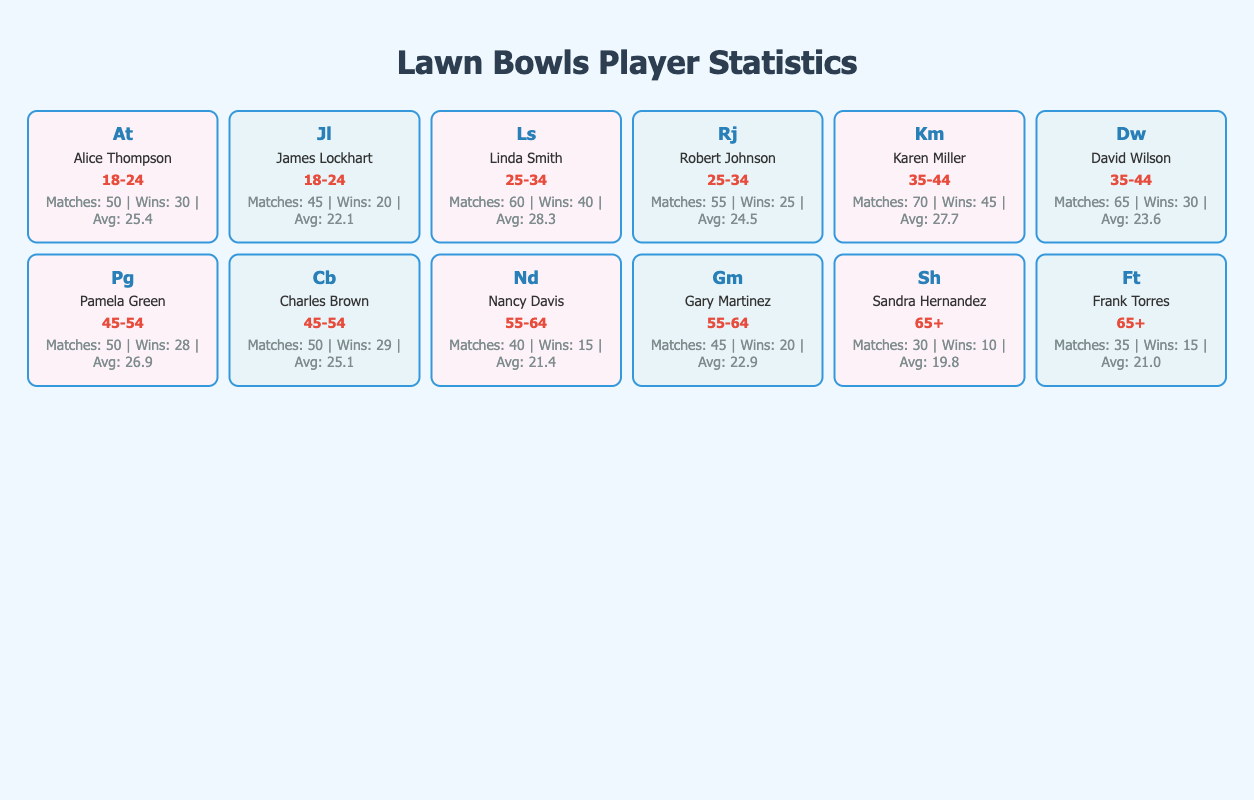What is the average score of players in the 35-44 age group? The average score for Karen Miller is 27.7 and for David Wilson it is 23.6. To find the average, we add these scores together: 27.7 + 23.6 = 51.3. Then we divide by the number of players in that age group, which is 2. Therefore, the average score is 51.3 / 2 = 25.65.
Answer: 25.65 How many total wins did male players in the 45-54 age group achieve? Charles Brown won 29 matches and David Wilson won 30 matches in the 45-54 age group. Adding these wins gives us 29 + 30 = 59 total wins for male players in this age group.
Answer: 59 Is it true that Nancy Davis has more losses than wins? Nancy Davis has 15 wins and 25 losses. Since 25 is greater than 15, this statement is true.
Answer: True Who played the most matches among female players aged 25-34? Linda Smith played 60 matches, and comparing it with the matches played by other female players in the same age group (which is none), we can conclude that she has the highest matches played in that group.
Answer: Linda Smith Which player in the 18-24 age group has a better winning percentage? Alice Thompson has 30 wins out of 50 matches (60% winning percentage), while James Lockhart has 20 wins out of 45 matches (44.4% winning percentage). Since 60% is greater than 44.4%, Alice Thompson has a better winning percentage.
Answer: Alice Thompson What is the difference in average score between the youngest and oldest players? The average score for Alice Thompson in the 18-24 age group is 25.4, while for Sandra Hernandez in the 65+ age group it is 19.8. The difference is calculated as 25.4 - 19.8 = 5.6.
Answer: 5.6 How many draws did Karen Miller and Pamela Green have combined? Karen Miller had 5 draws and Pamela Green had 2 draws. Adding these together gives us 5 + 2 = 7 combined draws.
Answer: 7 Which gender has more total wins across all age groups? To determine this, we sum the wins for females: 30 + 40 + 45 + 28 + 15 + 10 = 168, and for males: 20 + 25 + 30 + 29 + 20 + 15 = 139. Since 168 is greater than 139, females have more total wins.
Answer: Female Are there any players who have played exactly 50 matches? Looking through the data, Alice Thompson, Pamela Green, and Charles Brown each have 50 matches played. Therefore, there are players that meet this criterion.
Answer: Yes 